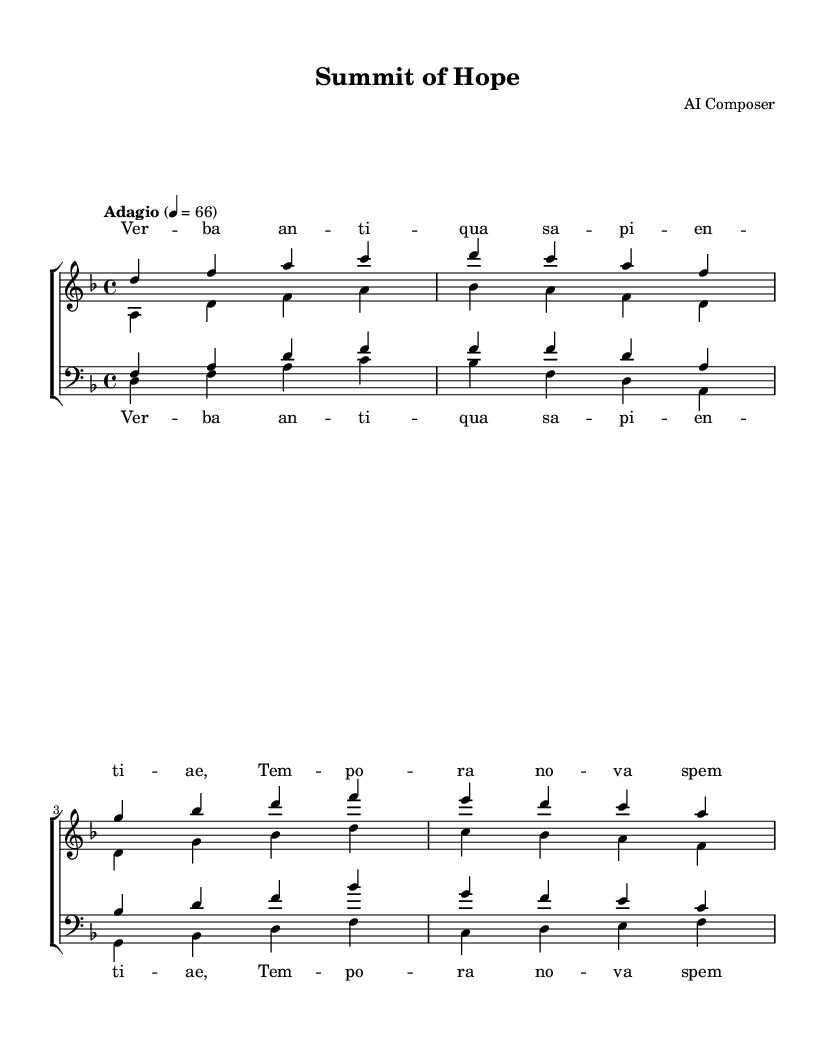What is the key signature of this music? The music is in D minor, which has one flat (B flat) in its key signature.
Answer: D minor What is the time signature of this music? The time signature is indicated at the beginning as 4/4, meaning there are four beats in each measure, and a quarter note gets one beat.
Answer: 4/4 What is the tempo marking of this piece? The tempo marking is "Adagio" with a metronome marking of 66, indicating a slow pace.
Answer: Adagio How many voices are present in the choir arrangement? The arrangement features four voices: soprano, alto, tenor, and bass.
Answer: Four Which lyric is sung by the sopranos? The initial lyrics for the sopranos begin with "Ver - ba an - ti - qua sa - pi - en - ti - ae."
Answer: Ver - ba an - ti - qua sa - pi - en - ti - ae What harmonic quality can be noted from the bass part? The bass part outlines the roots of the harmonies used in the piece, primarily shifting between D, B flat, and G, establishing a solid foundation.
Answer: Root progression What is the overall mood conveyed by the musical composition? The combination of the minor key, slow tempo, and choral arrangement creates a somber yet hopeful mood that complements the theme of pivotal moments in international relations.
Answer: Somber yet hopeful 